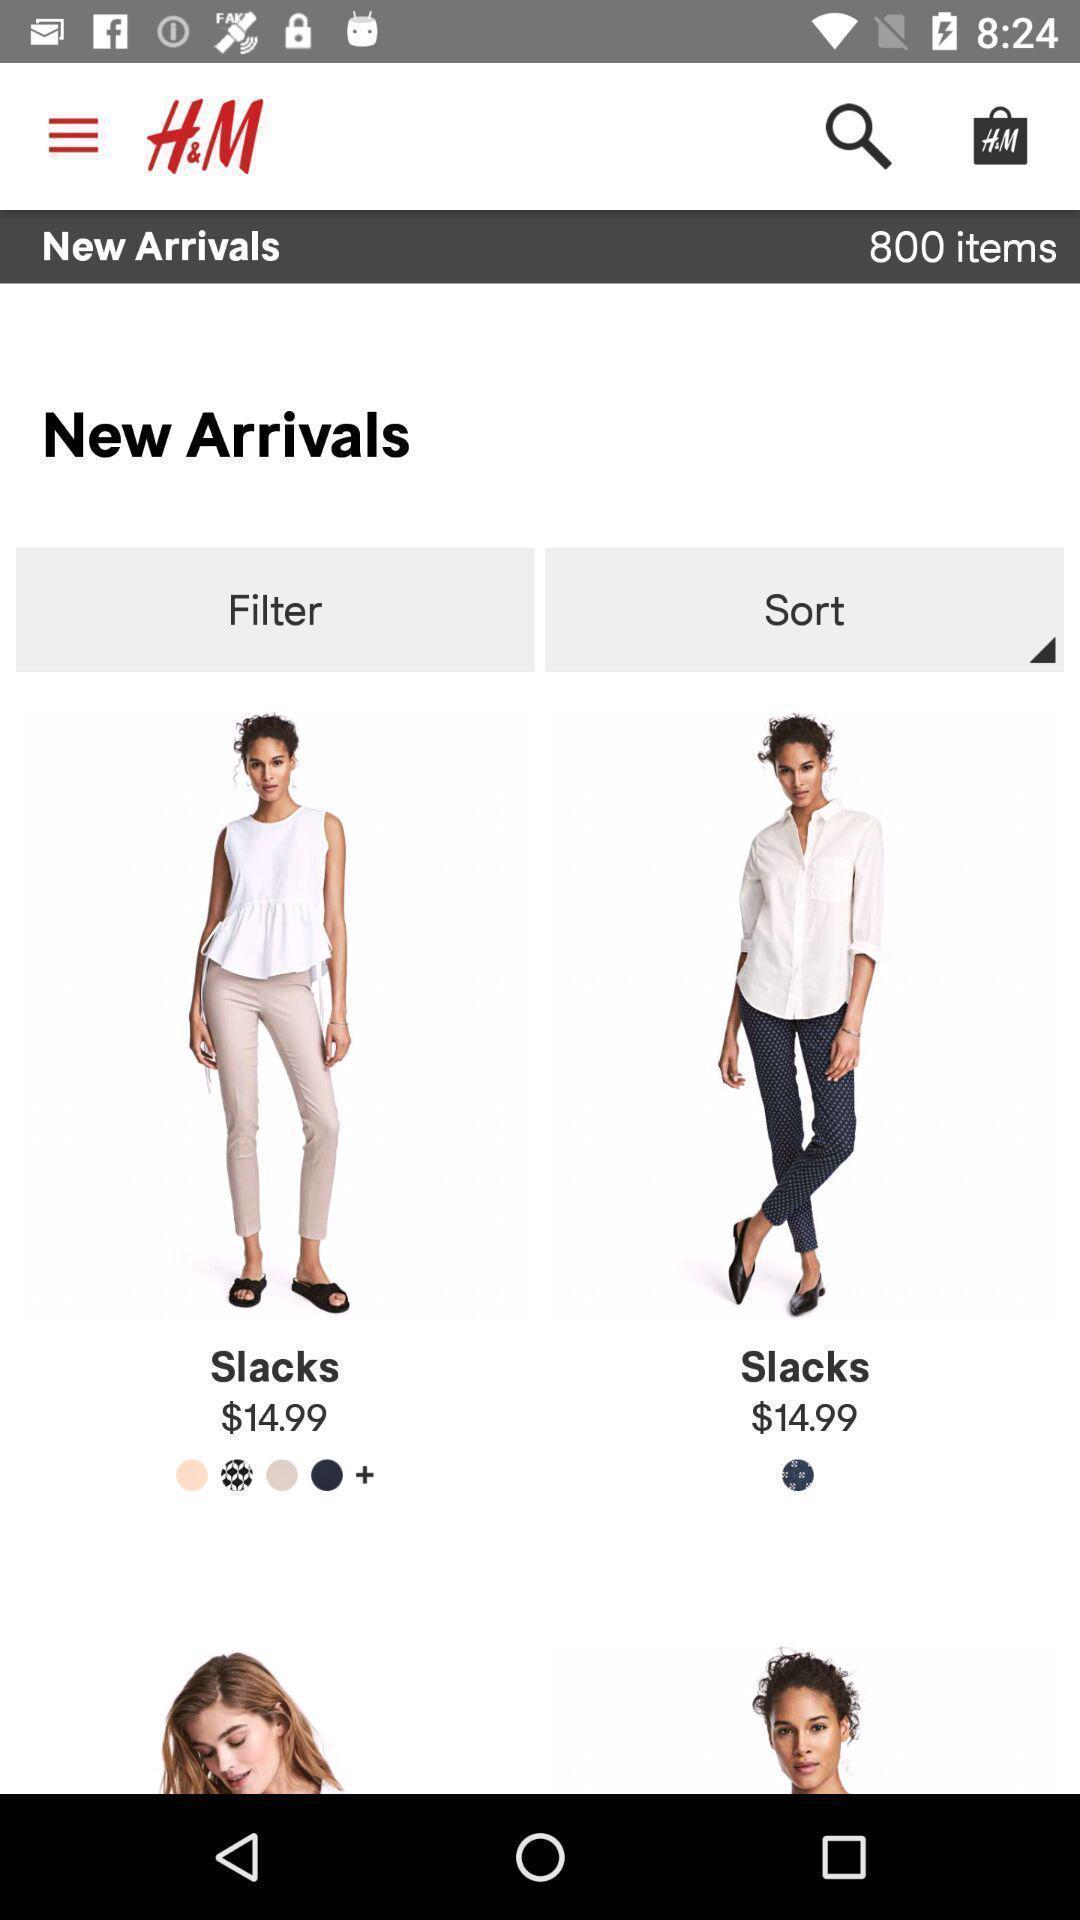Tell me about the visual elements in this screen capture. Page of an shopping application. 